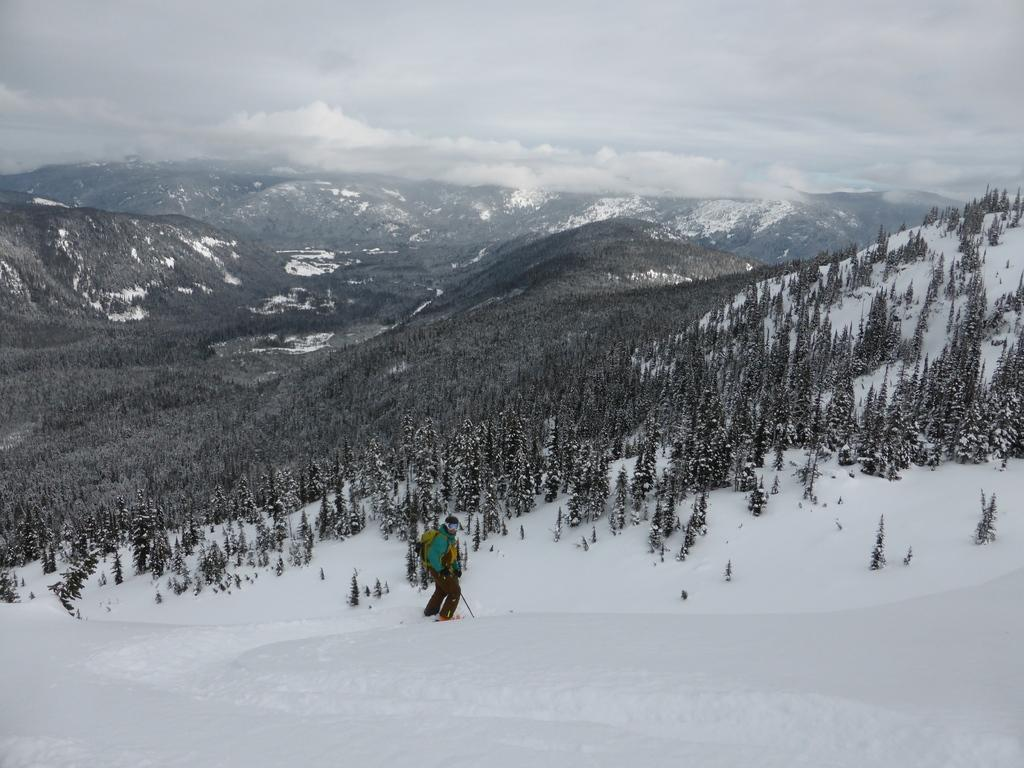What is the main subject of the image? There is a person in the image. What is the person wearing? The person is wearing a bag. What is the person holding? The person is holding a stick. What type of terrain is the person standing on? The person is standing on snow. What can be seen in the background of the image? There is a group of trees and the sky visible in the background of the image. How many dimes are visible on the person's head in the image? There are no dimes visible on the person's head in the image. What shape is the person drawing in the snow with the stick? There is no indication in the image that the person is drawing anything with the stick. 